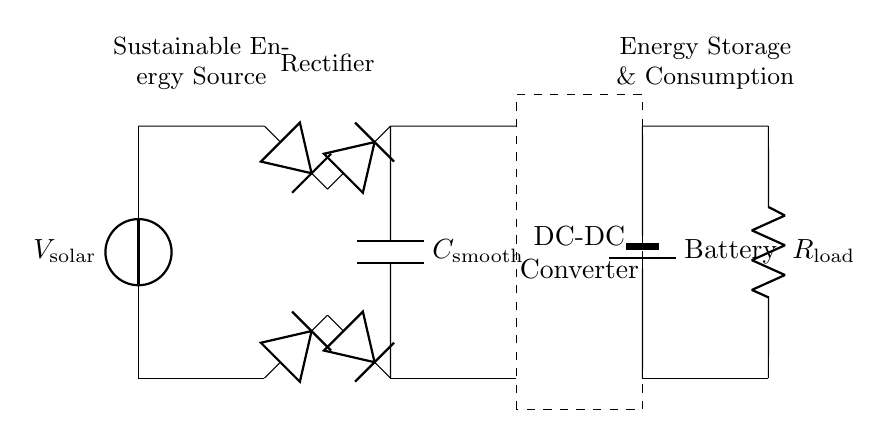What is the source of power in this circuit? The power source is labeled as V_solar, representing the output of the solar panel. This is the component supplying energy to the circuit.
Answer: V_solar What is the function of the diode bridge in this circuit? The diode bridge consists of four diodes that convert alternating current from the solar panel to direct current for the rest of the circuit, allowing current to flow in one direction.
Answer: Rectification What component is used for smoothing the output voltage? The component labeled C_smooth is a capacitor that smooths out fluctuations in the output voltage from the rectifier. It helps maintain a more constant voltage level.
Answer: C_smooth What is the main purpose of the DC-DC converter? The DC-DC converter adjusts the voltage level from the rectified output to a suitable level for the battery and load, ensuring efficient energy storage and use.
Answer: Voltage adjustment How many diodes are present in the rectifier bridge? There are four diodes in the rectifier bridge, which facilitate the direct conversion of AC to DC by allowing current to pass in only one direction.
Answer: Four What is the final energy output of this circuit? The final energy output after the battery is consumed by the load, specifically through the resistor labeled R_load, which represents the actual energy consumption point.
Answer: R_load 